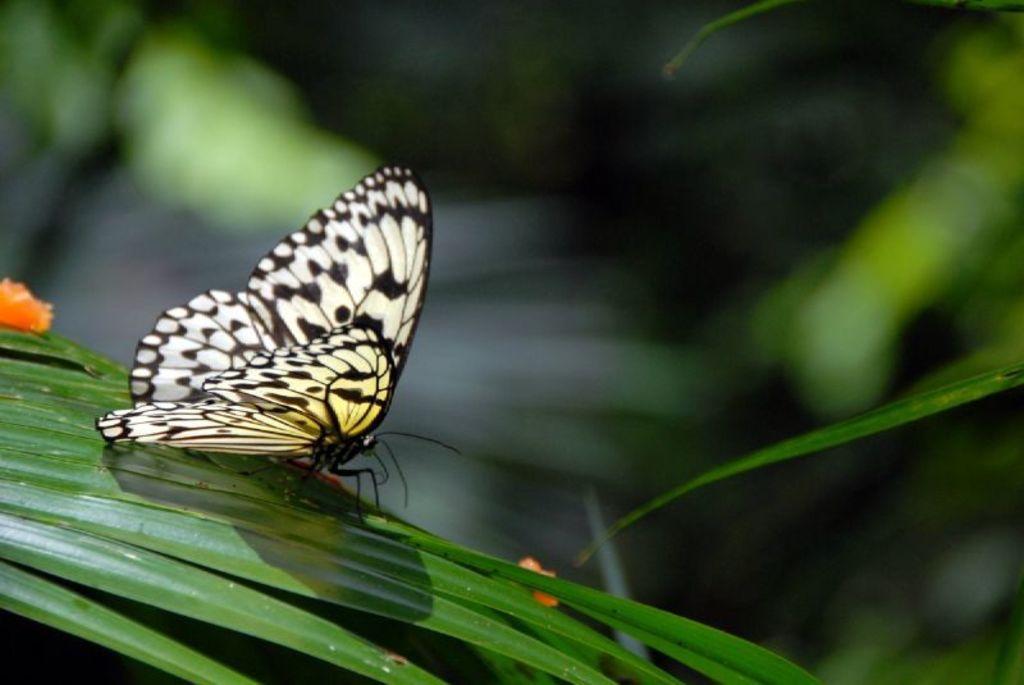How would you summarize this image in a sentence or two? In this image I can see a butterfly which is white, black and yellow in color on the green colored leaf. I can see few orange colored objects and the blurry background. 